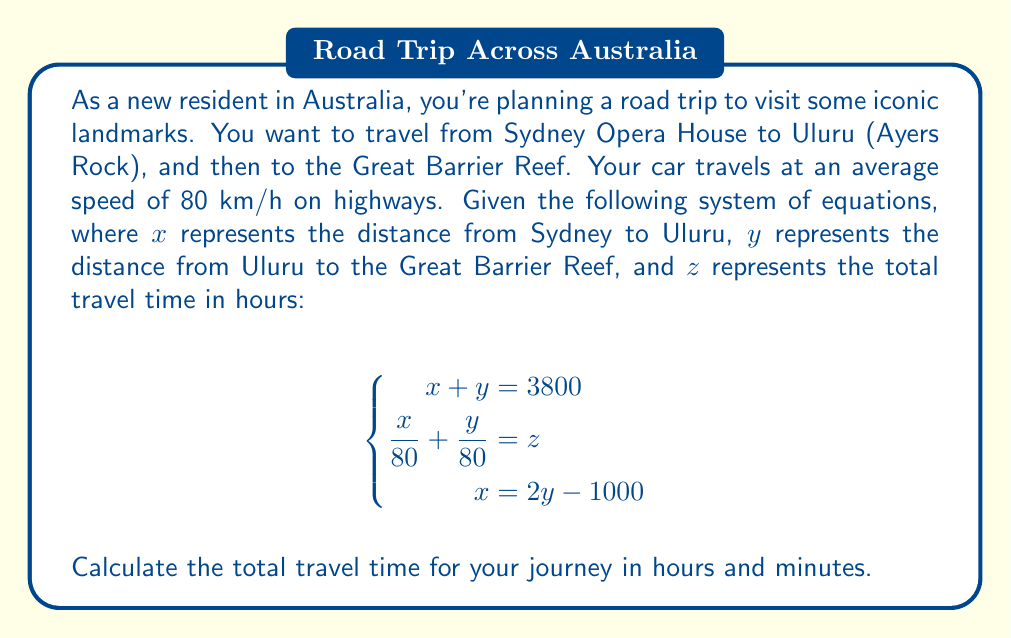Can you solve this math problem? Let's solve this system of equations step by step:

1) From the third equation, we can express $x$ in terms of $y$:
   $x = 2y - 1000$

2) Substitute this into the first equation:
   $(2y - 1000) + y = 3800$
   $3y - 1000 = 3800$
   $3y = 4800$
   $y = 1600$

3) Now we can find $x$:
   $x = 2(1600) - 1000 = 2200$

4) To find $z$, we use the second equation:
   $\frac{x}{80} + \frac{y}{80} = z$
   $\frac{2200}{80} + \frac{1600}{80} = z$
   $27.5 + 20 = z$
   $z = 47.5$

5) Convert 0.5 hours to minutes:
   $0.5 \times 60 = 30$ minutes

Therefore, the total travel time is 47 hours and 30 minutes.
Answer: 47 hours and 30 minutes 